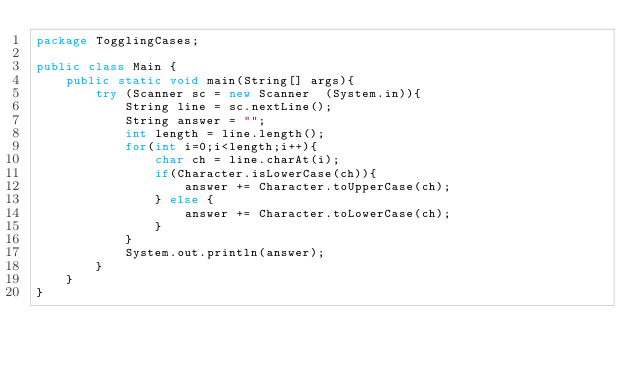<code> <loc_0><loc_0><loc_500><loc_500><_Java_>package TogglingCases;

public class Main {
    public static void main(String[] args){
        try (Scanner sc = new Scanner  (System.in)){
            String line = sc.nextLine();
            String answer = "";
            int length = line.length();
            for(int i=0;i<length;i++){
                char ch = line.charAt(i);
                if(Character.isLowerCase(ch)){
                    answer += Character.toUpperCase(ch);
                } else {
                    answer += Character.toLowerCase(ch);
                }
            }
            System.out.println(answer);
        }
    }
}

</code> 